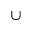<formula> <loc_0><loc_0><loc_500><loc_500>\cup</formula> 